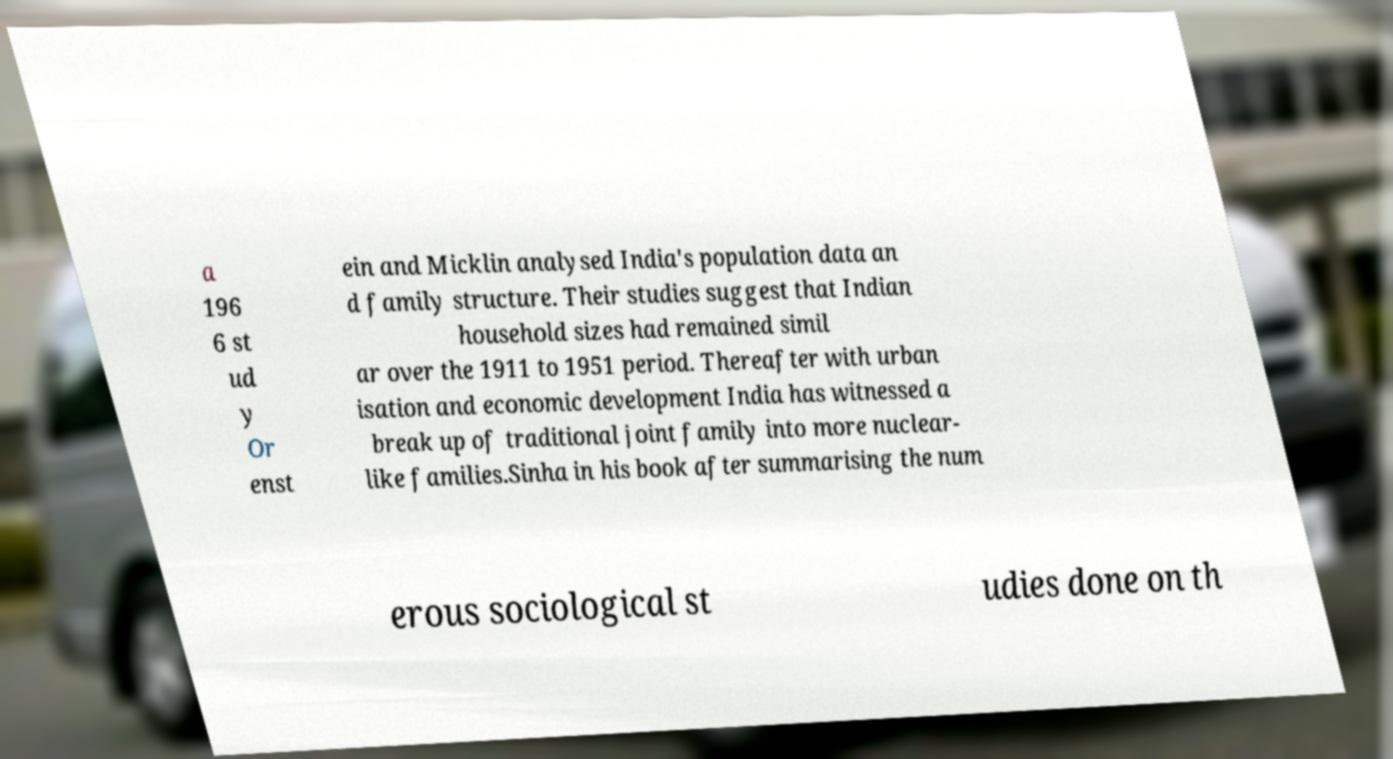Please read and relay the text visible in this image. What does it say? a 196 6 st ud y Or enst ein and Micklin analysed India's population data an d family structure. Their studies suggest that Indian household sizes had remained simil ar over the 1911 to 1951 period. Thereafter with urban isation and economic development India has witnessed a break up of traditional joint family into more nuclear- like families.Sinha in his book after summarising the num erous sociological st udies done on th 